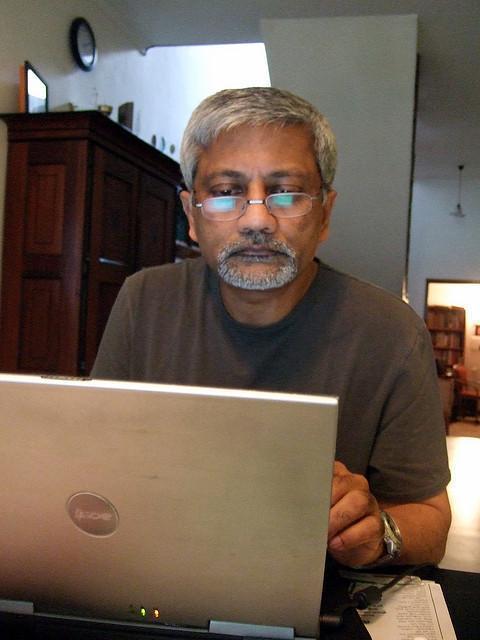How many blue ties are there?
Give a very brief answer. 0. 